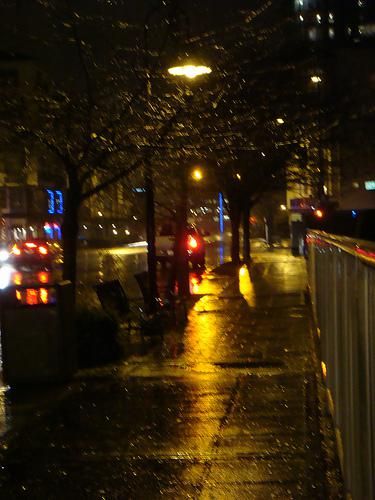Question: how is the weather?
Choices:
A. It is sunny.
B. It is raining.
C. It is windy.
D. It is cloudy.
Answer with the letter. Answer: B Question: where are the people?
Choices:
A. They're gone.
B. No one is around.
C. They left.
D. They are away.
Answer with the letter. Answer: B Question: why are the sidewalks shiny?
Choices:
A. They are slidy.
B. They are lit.
C. They are painted.
D. They are wet.
Answer with the letter. Answer: D Question: what is driving down the street?
Choices:
A. Trains.
B. Vehicles.
C. Bicycles.
D. Motorcycles.
Answer with the letter. Answer: B Question: what is lining the sidewalk?
Choices:
A. Buildings.
B. Trees.
C. Fences.
D. Poles.
Answer with the letter. Answer: B Question: what sits under the trees?
Choices:
A. Benches.
B. Chairs.
C. Stools.
D. Tables.
Answer with the letter. Answer: A 